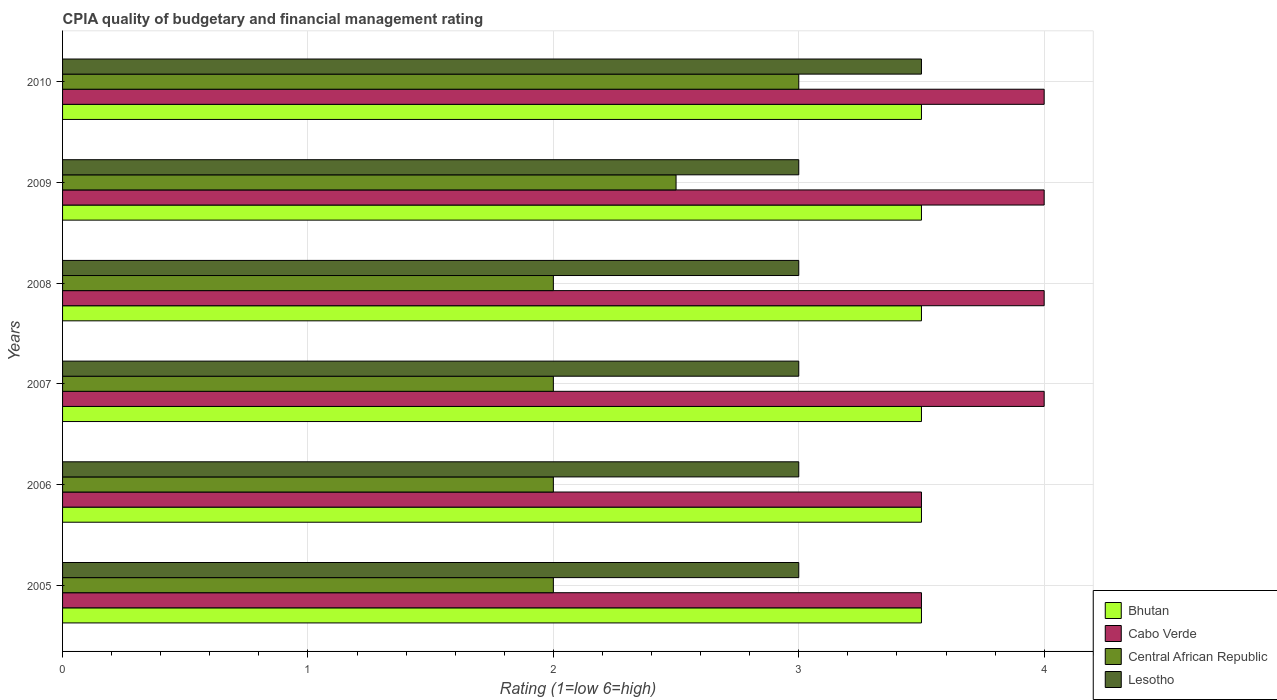Are the number of bars on each tick of the Y-axis equal?
Give a very brief answer. Yes. How many bars are there on the 3rd tick from the top?
Provide a succinct answer. 4. How many bars are there on the 5th tick from the bottom?
Keep it short and to the point. 4. In how many cases, is the number of bars for a given year not equal to the number of legend labels?
Provide a succinct answer. 0. What is the CPIA rating in Lesotho in 2006?
Your response must be concise. 3. Across all years, what is the minimum CPIA rating in Bhutan?
Your answer should be compact. 3.5. In which year was the CPIA rating in Cabo Verde maximum?
Offer a very short reply. 2007. What is the total CPIA rating in Cabo Verde in the graph?
Offer a very short reply. 23. What is the difference between the CPIA rating in Bhutan in 2008 and that in 2010?
Keep it short and to the point. 0. What is the average CPIA rating in Cabo Verde per year?
Ensure brevity in your answer.  3.83. What is the ratio of the CPIA rating in Central African Republic in 2005 to that in 2008?
Provide a short and direct response. 1. What is the difference between the highest and the second highest CPIA rating in Cabo Verde?
Make the answer very short. 0. Is the sum of the CPIA rating in Cabo Verde in 2008 and 2010 greater than the maximum CPIA rating in Central African Republic across all years?
Make the answer very short. Yes. Is it the case that in every year, the sum of the CPIA rating in Bhutan and CPIA rating in Central African Republic is greater than the sum of CPIA rating in Cabo Verde and CPIA rating in Lesotho?
Give a very brief answer. No. What does the 1st bar from the top in 2005 represents?
Keep it short and to the point. Lesotho. What does the 3rd bar from the bottom in 2006 represents?
Make the answer very short. Central African Republic. Are all the bars in the graph horizontal?
Provide a short and direct response. Yes. Are the values on the major ticks of X-axis written in scientific E-notation?
Provide a short and direct response. No. Does the graph contain any zero values?
Offer a very short reply. No. Does the graph contain grids?
Keep it short and to the point. Yes. Where does the legend appear in the graph?
Give a very brief answer. Bottom right. What is the title of the graph?
Provide a short and direct response. CPIA quality of budgetary and financial management rating. What is the label or title of the Y-axis?
Provide a short and direct response. Years. What is the Rating (1=low 6=high) of Cabo Verde in 2005?
Ensure brevity in your answer.  3.5. What is the Rating (1=low 6=high) in Central African Republic in 2005?
Offer a very short reply. 2. What is the Rating (1=low 6=high) of Cabo Verde in 2007?
Your response must be concise. 4. What is the Rating (1=low 6=high) of Bhutan in 2008?
Your response must be concise. 3.5. What is the Rating (1=low 6=high) of Cabo Verde in 2008?
Your response must be concise. 4. What is the Rating (1=low 6=high) of Bhutan in 2010?
Offer a terse response. 3.5. What is the Rating (1=low 6=high) in Lesotho in 2010?
Make the answer very short. 3.5. Across all years, what is the maximum Rating (1=low 6=high) of Bhutan?
Provide a succinct answer. 3.5. Across all years, what is the maximum Rating (1=low 6=high) of Cabo Verde?
Provide a succinct answer. 4. Across all years, what is the maximum Rating (1=low 6=high) of Central African Republic?
Keep it short and to the point. 3. Across all years, what is the minimum Rating (1=low 6=high) of Cabo Verde?
Offer a very short reply. 3.5. Across all years, what is the minimum Rating (1=low 6=high) in Central African Republic?
Give a very brief answer. 2. Across all years, what is the minimum Rating (1=low 6=high) of Lesotho?
Give a very brief answer. 3. What is the total Rating (1=low 6=high) of Cabo Verde in the graph?
Give a very brief answer. 23. What is the total Rating (1=low 6=high) in Central African Republic in the graph?
Provide a succinct answer. 13.5. What is the difference between the Rating (1=low 6=high) of Cabo Verde in 2005 and that in 2006?
Keep it short and to the point. 0. What is the difference between the Rating (1=low 6=high) of Bhutan in 2005 and that in 2007?
Keep it short and to the point. 0. What is the difference between the Rating (1=low 6=high) in Cabo Verde in 2005 and that in 2007?
Offer a terse response. -0.5. What is the difference between the Rating (1=low 6=high) of Lesotho in 2005 and that in 2007?
Your answer should be very brief. 0. What is the difference between the Rating (1=low 6=high) of Bhutan in 2005 and that in 2008?
Your answer should be compact. 0. What is the difference between the Rating (1=low 6=high) in Cabo Verde in 2005 and that in 2008?
Provide a short and direct response. -0.5. What is the difference between the Rating (1=low 6=high) of Lesotho in 2005 and that in 2008?
Ensure brevity in your answer.  0. What is the difference between the Rating (1=low 6=high) in Cabo Verde in 2005 and that in 2009?
Your response must be concise. -0.5. What is the difference between the Rating (1=low 6=high) in Lesotho in 2005 and that in 2009?
Provide a succinct answer. 0. What is the difference between the Rating (1=low 6=high) of Cabo Verde in 2005 and that in 2010?
Offer a very short reply. -0.5. What is the difference between the Rating (1=low 6=high) of Lesotho in 2005 and that in 2010?
Ensure brevity in your answer.  -0.5. What is the difference between the Rating (1=low 6=high) of Cabo Verde in 2006 and that in 2007?
Make the answer very short. -0.5. What is the difference between the Rating (1=low 6=high) of Central African Republic in 2006 and that in 2007?
Provide a short and direct response. 0. What is the difference between the Rating (1=low 6=high) in Lesotho in 2006 and that in 2007?
Keep it short and to the point. 0. What is the difference between the Rating (1=low 6=high) of Cabo Verde in 2006 and that in 2008?
Your response must be concise. -0.5. What is the difference between the Rating (1=low 6=high) in Lesotho in 2006 and that in 2008?
Provide a short and direct response. 0. What is the difference between the Rating (1=low 6=high) of Cabo Verde in 2006 and that in 2009?
Ensure brevity in your answer.  -0.5. What is the difference between the Rating (1=low 6=high) of Central African Republic in 2006 and that in 2009?
Ensure brevity in your answer.  -0.5. What is the difference between the Rating (1=low 6=high) of Lesotho in 2006 and that in 2009?
Offer a very short reply. 0. What is the difference between the Rating (1=low 6=high) of Bhutan in 2006 and that in 2010?
Offer a very short reply. 0. What is the difference between the Rating (1=low 6=high) of Cabo Verde in 2006 and that in 2010?
Offer a terse response. -0.5. What is the difference between the Rating (1=low 6=high) in Central African Republic in 2006 and that in 2010?
Provide a succinct answer. -1. What is the difference between the Rating (1=low 6=high) in Bhutan in 2007 and that in 2008?
Your answer should be very brief. 0. What is the difference between the Rating (1=low 6=high) in Cabo Verde in 2007 and that in 2008?
Ensure brevity in your answer.  0. What is the difference between the Rating (1=low 6=high) in Central African Republic in 2007 and that in 2008?
Keep it short and to the point. 0. What is the difference between the Rating (1=low 6=high) of Bhutan in 2007 and that in 2009?
Ensure brevity in your answer.  0. What is the difference between the Rating (1=low 6=high) in Cabo Verde in 2007 and that in 2009?
Make the answer very short. 0. What is the difference between the Rating (1=low 6=high) in Lesotho in 2007 and that in 2009?
Your answer should be very brief. 0. What is the difference between the Rating (1=low 6=high) in Bhutan in 2007 and that in 2010?
Offer a terse response. 0. What is the difference between the Rating (1=low 6=high) of Central African Republic in 2007 and that in 2010?
Your response must be concise. -1. What is the difference between the Rating (1=low 6=high) of Bhutan in 2008 and that in 2009?
Your answer should be compact. 0. What is the difference between the Rating (1=low 6=high) in Cabo Verde in 2008 and that in 2010?
Provide a succinct answer. 0. What is the difference between the Rating (1=low 6=high) in Central African Republic in 2008 and that in 2010?
Keep it short and to the point. -1. What is the difference between the Rating (1=low 6=high) of Lesotho in 2008 and that in 2010?
Provide a succinct answer. -0.5. What is the difference between the Rating (1=low 6=high) in Bhutan in 2009 and that in 2010?
Give a very brief answer. 0. What is the difference between the Rating (1=low 6=high) of Cabo Verde in 2005 and the Rating (1=low 6=high) of Central African Republic in 2006?
Your response must be concise. 1.5. What is the difference between the Rating (1=low 6=high) of Central African Republic in 2005 and the Rating (1=low 6=high) of Lesotho in 2006?
Provide a short and direct response. -1. What is the difference between the Rating (1=low 6=high) of Bhutan in 2005 and the Rating (1=low 6=high) of Cabo Verde in 2007?
Keep it short and to the point. -0.5. What is the difference between the Rating (1=low 6=high) in Bhutan in 2005 and the Rating (1=low 6=high) in Lesotho in 2007?
Offer a very short reply. 0.5. What is the difference between the Rating (1=low 6=high) in Cabo Verde in 2005 and the Rating (1=low 6=high) in Central African Republic in 2007?
Your answer should be very brief. 1.5. What is the difference between the Rating (1=low 6=high) of Bhutan in 2005 and the Rating (1=low 6=high) of Lesotho in 2008?
Your answer should be very brief. 0.5. What is the difference between the Rating (1=low 6=high) in Cabo Verde in 2005 and the Rating (1=low 6=high) in Central African Republic in 2008?
Make the answer very short. 1.5. What is the difference between the Rating (1=low 6=high) in Cabo Verde in 2005 and the Rating (1=low 6=high) in Lesotho in 2008?
Your answer should be very brief. 0.5. What is the difference between the Rating (1=low 6=high) of Bhutan in 2005 and the Rating (1=low 6=high) of Lesotho in 2009?
Offer a terse response. 0.5. What is the difference between the Rating (1=low 6=high) in Cabo Verde in 2005 and the Rating (1=low 6=high) in Central African Republic in 2009?
Keep it short and to the point. 1. What is the difference between the Rating (1=low 6=high) in Central African Republic in 2005 and the Rating (1=low 6=high) in Lesotho in 2009?
Offer a terse response. -1. What is the difference between the Rating (1=low 6=high) in Bhutan in 2005 and the Rating (1=low 6=high) in Cabo Verde in 2010?
Ensure brevity in your answer.  -0.5. What is the difference between the Rating (1=low 6=high) of Bhutan in 2005 and the Rating (1=low 6=high) of Central African Republic in 2010?
Provide a succinct answer. 0.5. What is the difference between the Rating (1=low 6=high) in Cabo Verde in 2005 and the Rating (1=low 6=high) in Central African Republic in 2010?
Keep it short and to the point. 0.5. What is the difference between the Rating (1=low 6=high) of Central African Republic in 2005 and the Rating (1=low 6=high) of Lesotho in 2010?
Give a very brief answer. -1.5. What is the difference between the Rating (1=low 6=high) of Bhutan in 2006 and the Rating (1=low 6=high) of Central African Republic in 2007?
Give a very brief answer. 1.5. What is the difference between the Rating (1=low 6=high) of Bhutan in 2006 and the Rating (1=low 6=high) of Lesotho in 2007?
Ensure brevity in your answer.  0.5. What is the difference between the Rating (1=low 6=high) in Cabo Verde in 2006 and the Rating (1=low 6=high) in Central African Republic in 2007?
Your answer should be compact. 1.5. What is the difference between the Rating (1=low 6=high) of Cabo Verde in 2006 and the Rating (1=low 6=high) of Lesotho in 2007?
Ensure brevity in your answer.  0.5. What is the difference between the Rating (1=low 6=high) in Bhutan in 2006 and the Rating (1=low 6=high) in Lesotho in 2008?
Your answer should be compact. 0.5. What is the difference between the Rating (1=low 6=high) of Central African Republic in 2006 and the Rating (1=low 6=high) of Lesotho in 2008?
Your answer should be compact. -1. What is the difference between the Rating (1=low 6=high) in Bhutan in 2006 and the Rating (1=low 6=high) in Cabo Verde in 2009?
Provide a succinct answer. -0.5. What is the difference between the Rating (1=low 6=high) in Cabo Verde in 2006 and the Rating (1=low 6=high) in Lesotho in 2009?
Your response must be concise. 0.5. What is the difference between the Rating (1=low 6=high) of Central African Republic in 2006 and the Rating (1=low 6=high) of Lesotho in 2009?
Your response must be concise. -1. What is the difference between the Rating (1=low 6=high) of Bhutan in 2006 and the Rating (1=low 6=high) of Cabo Verde in 2010?
Keep it short and to the point. -0.5. What is the difference between the Rating (1=low 6=high) in Bhutan in 2006 and the Rating (1=low 6=high) in Central African Republic in 2010?
Ensure brevity in your answer.  0.5. What is the difference between the Rating (1=low 6=high) of Bhutan in 2006 and the Rating (1=low 6=high) of Lesotho in 2010?
Your response must be concise. 0. What is the difference between the Rating (1=low 6=high) in Central African Republic in 2006 and the Rating (1=low 6=high) in Lesotho in 2010?
Your answer should be compact. -1.5. What is the difference between the Rating (1=low 6=high) of Bhutan in 2007 and the Rating (1=low 6=high) of Lesotho in 2008?
Provide a succinct answer. 0.5. What is the difference between the Rating (1=low 6=high) of Cabo Verde in 2007 and the Rating (1=low 6=high) of Lesotho in 2008?
Your response must be concise. 1. What is the difference between the Rating (1=low 6=high) of Bhutan in 2007 and the Rating (1=low 6=high) of Cabo Verde in 2009?
Your answer should be compact. -0.5. What is the difference between the Rating (1=low 6=high) in Bhutan in 2007 and the Rating (1=low 6=high) in Central African Republic in 2009?
Your response must be concise. 1. What is the difference between the Rating (1=low 6=high) of Bhutan in 2007 and the Rating (1=low 6=high) of Lesotho in 2009?
Your answer should be very brief. 0.5. What is the difference between the Rating (1=low 6=high) of Cabo Verde in 2007 and the Rating (1=low 6=high) of Lesotho in 2009?
Provide a succinct answer. 1. What is the difference between the Rating (1=low 6=high) in Bhutan in 2007 and the Rating (1=low 6=high) in Cabo Verde in 2010?
Your answer should be very brief. -0.5. What is the difference between the Rating (1=low 6=high) of Bhutan in 2007 and the Rating (1=low 6=high) of Central African Republic in 2010?
Make the answer very short. 0.5. What is the difference between the Rating (1=low 6=high) of Cabo Verde in 2007 and the Rating (1=low 6=high) of Lesotho in 2010?
Your answer should be compact. 0.5. What is the difference between the Rating (1=low 6=high) of Bhutan in 2008 and the Rating (1=low 6=high) of Cabo Verde in 2009?
Your answer should be very brief. -0.5. What is the difference between the Rating (1=low 6=high) in Bhutan in 2008 and the Rating (1=low 6=high) in Lesotho in 2009?
Your response must be concise. 0.5. What is the difference between the Rating (1=low 6=high) in Cabo Verde in 2008 and the Rating (1=low 6=high) in Central African Republic in 2009?
Provide a succinct answer. 1.5. What is the difference between the Rating (1=low 6=high) in Cabo Verde in 2008 and the Rating (1=low 6=high) in Lesotho in 2009?
Provide a short and direct response. 1. What is the difference between the Rating (1=low 6=high) of Central African Republic in 2008 and the Rating (1=low 6=high) of Lesotho in 2009?
Provide a short and direct response. -1. What is the difference between the Rating (1=low 6=high) in Bhutan in 2008 and the Rating (1=low 6=high) in Lesotho in 2010?
Keep it short and to the point. 0. What is the difference between the Rating (1=low 6=high) of Cabo Verde in 2008 and the Rating (1=low 6=high) of Lesotho in 2010?
Ensure brevity in your answer.  0.5. What is the difference between the Rating (1=low 6=high) in Central African Republic in 2008 and the Rating (1=low 6=high) in Lesotho in 2010?
Ensure brevity in your answer.  -1.5. What is the difference between the Rating (1=low 6=high) of Bhutan in 2009 and the Rating (1=low 6=high) of Cabo Verde in 2010?
Offer a very short reply. -0.5. What is the difference between the Rating (1=low 6=high) of Bhutan in 2009 and the Rating (1=low 6=high) of Central African Republic in 2010?
Offer a terse response. 0.5. What is the difference between the Rating (1=low 6=high) in Cabo Verde in 2009 and the Rating (1=low 6=high) in Lesotho in 2010?
Provide a succinct answer. 0.5. What is the average Rating (1=low 6=high) in Cabo Verde per year?
Offer a terse response. 3.83. What is the average Rating (1=low 6=high) of Central African Republic per year?
Offer a very short reply. 2.25. What is the average Rating (1=low 6=high) in Lesotho per year?
Make the answer very short. 3.08. In the year 2005, what is the difference between the Rating (1=low 6=high) in Bhutan and Rating (1=low 6=high) in Cabo Verde?
Provide a succinct answer. 0. In the year 2005, what is the difference between the Rating (1=low 6=high) in Bhutan and Rating (1=low 6=high) in Central African Republic?
Your response must be concise. 1.5. In the year 2005, what is the difference between the Rating (1=low 6=high) of Bhutan and Rating (1=low 6=high) of Lesotho?
Offer a very short reply. 0.5. In the year 2005, what is the difference between the Rating (1=low 6=high) of Cabo Verde and Rating (1=low 6=high) of Central African Republic?
Keep it short and to the point. 1.5. In the year 2005, what is the difference between the Rating (1=low 6=high) in Central African Republic and Rating (1=low 6=high) in Lesotho?
Give a very brief answer. -1. In the year 2006, what is the difference between the Rating (1=low 6=high) of Bhutan and Rating (1=low 6=high) of Central African Republic?
Provide a short and direct response. 1.5. In the year 2007, what is the difference between the Rating (1=low 6=high) in Cabo Verde and Rating (1=low 6=high) in Central African Republic?
Offer a very short reply. 2. In the year 2008, what is the difference between the Rating (1=low 6=high) in Bhutan and Rating (1=low 6=high) in Cabo Verde?
Provide a succinct answer. -0.5. In the year 2008, what is the difference between the Rating (1=low 6=high) of Bhutan and Rating (1=low 6=high) of Central African Republic?
Give a very brief answer. 1.5. In the year 2008, what is the difference between the Rating (1=low 6=high) in Bhutan and Rating (1=low 6=high) in Lesotho?
Your response must be concise. 0.5. In the year 2008, what is the difference between the Rating (1=low 6=high) of Cabo Verde and Rating (1=low 6=high) of Central African Republic?
Your answer should be compact. 2. In the year 2008, what is the difference between the Rating (1=low 6=high) of Cabo Verde and Rating (1=low 6=high) of Lesotho?
Give a very brief answer. 1. In the year 2008, what is the difference between the Rating (1=low 6=high) of Central African Republic and Rating (1=low 6=high) of Lesotho?
Make the answer very short. -1. In the year 2009, what is the difference between the Rating (1=low 6=high) in Bhutan and Rating (1=low 6=high) in Central African Republic?
Make the answer very short. 1. In the year 2009, what is the difference between the Rating (1=low 6=high) of Cabo Verde and Rating (1=low 6=high) of Lesotho?
Provide a succinct answer. 1. In the year 2009, what is the difference between the Rating (1=low 6=high) in Central African Republic and Rating (1=low 6=high) in Lesotho?
Provide a short and direct response. -0.5. In the year 2010, what is the difference between the Rating (1=low 6=high) in Bhutan and Rating (1=low 6=high) in Central African Republic?
Offer a very short reply. 0.5. In the year 2010, what is the difference between the Rating (1=low 6=high) of Bhutan and Rating (1=low 6=high) of Lesotho?
Provide a succinct answer. 0. In the year 2010, what is the difference between the Rating (1=low 6=high) of Cabo Verde and Rating (1=low 6=high) of Central African Republic?
Give a very brief answer. 1. In the year 2010, what is the difference between the Rating (1=low 6=high) in Central African Republic and Rating (1=low 6=high) in Lesotho?
Give a very brief answer. -0.5. What is the ratio of the Rating (1=low 6=high) of Bhutan in 2005 to that in 2006?
Your answer should be very brief. 1. What is the ratio of the Rating (1=low 6=high) of Cabo Verde in 2005 to that in 2006?
Give a very brief answer. 1. What is the ratio of the Rating (1=low 6=high) of Lesotho in 2005 to that in 2006?
Your answer should be very brief. 1. What is the ratio of the Rating (1=low 6=high) in Bhutan in 2005 to that in 2007?
Offer a terse response. 1. What is the ratio of the Rating (1=low 6=high) in Bhutan in 2005 to that in 2008?
Your answer should be very brief. 1. What is the ratio of the Rating (1=low 6=high) of Lesotho in 2005 to that in 2008?
Offer a very short reply. 1. What is the ratio of the Rating (1=low 6=high) in Bhutan in 2005 to that in 2009?
Make the answer very short. 1. What is the ratio of the Rating (1=low 6=high) in Central African Republic in 2005 to that in 2009?
Keep it short and to the point. 0.8. What is the ratio of the Rating (1=low 6=high) in Lesotho in 2005 to that in 2009?
Your response must be concise. 1. What is the ratio of the Rating (1=low 6=high) in Central African Republic in 2005 to that in 2010?
Your answer should be very brief. 0.67. What is the ratio of the Rating (1=low 6=high) in Lesotho in 2005 to that in 2010?
Make the answer very short. 0.86. What is the ratio of the Rating (1=low 6=high) in Cabo Verde in 2006 to that in 2008?
Give a very brief answer. 0.88. What is the ratio of the Rating (1=low 6=high) of Lesotho in 2006 to that in 2008?
Offer a terse response. 1. What is the ratio of the Rating (1=low 6=high) of Cabo Verde in 2006 to that in 2009?
Provide a succinct answer. 0.88. What is the ratio of the Rating (1=low 6=high) of Cabo Verde in 2006 to that in 2010?
Provide a succinct answer. 0.88. What is the ratio of the Rating (1=low 6=high) of Central African Republic in 2006 to that in 2010?
Your answer should be compact. 0.67. What is the ratio of the Rating (1=low 6=high) in Lesotho in 2006 to that in 2010?
Make the answer very short. 0.86. What is the ratio of the Rating (1=low 6=high) in Cabo Verde in 2007 to that in 2008?
Your answer should be very brief. 1. What is the ratio of the Rating (1=low 6=high) in Central African Republic in 2007 to that in 2008?
Give a very brief answer. 1. What is the ratio of the Rating (1=low 6=high) of Lesotho in 2007 to that in 2008?
Give a very brief answer. 1. What is the ratio of the Rating (1=low 6=high) of Bhutan in 2007 to that in 2009?
Your answer should be very brief. 1. What is the ratio of the Rating (1=low 6=high) of Cabo Verde in 2007 to that in 2009?
Give a very brief answer. 1. What is the ratio of the Rating (1=low 6=high) of Bhutan in 2007 to that in 2010?
Keep it short and to the point. 1. What is the ratio of the Rating (1=low 6=high) of Cabo Verde in 2007 to that in 2010?
Ensure brevity in your answer.  1. What is the ratio of the Rating (1=low 6=high) in Cabo Verde in 2008 to that in 2009?
Your answer should be very brief. 1. What is the ratio of the Rating (1=low 6=high) in Central African Republic in 2008 to that in 2009?
Make the answer very short. 0.8. What is the ratio of the Rating (1=low 6=high) of Bhutan in 2008 to that in 2010?
Give a very brief answer. 1. What is the ratio of the Rating (1=low 6=high) in Central African Republic in 2008 to that in 2010?
Your answer should be compact. 0.67. What is the difference between the highest and the second highest Rating (1=low 6=high) in Lesotho?
Keep it short and to the point. 0.5. What is the difference between the highest and the lowest Rating (1=low 6=high) of Cabo Verde?
Offer a terse response. 0.5. What is the difference between the highest and the lowest Rating (1=low 6=high) in Lesotho?
Give a very brief answer. 0.5. 